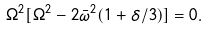Convert formula to latex. <formula><loc_0><loc_0><loc_500><loc_500>\Omega ^ { 2 } [ \Omega ^ { 2 } - 2 \bar { \omega } ^ { 2 } ( 1 + \delta / 3 ) ] = 0 .</formula> 